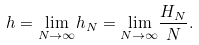<formula> <loc_0><loc_0><loc_500><loc_500>h = \underset { N \to \infty } { \lim } h _ { N } = \underset { N \to \infty } { \lim } \frac { H _ { N } } { N } .</formula> 